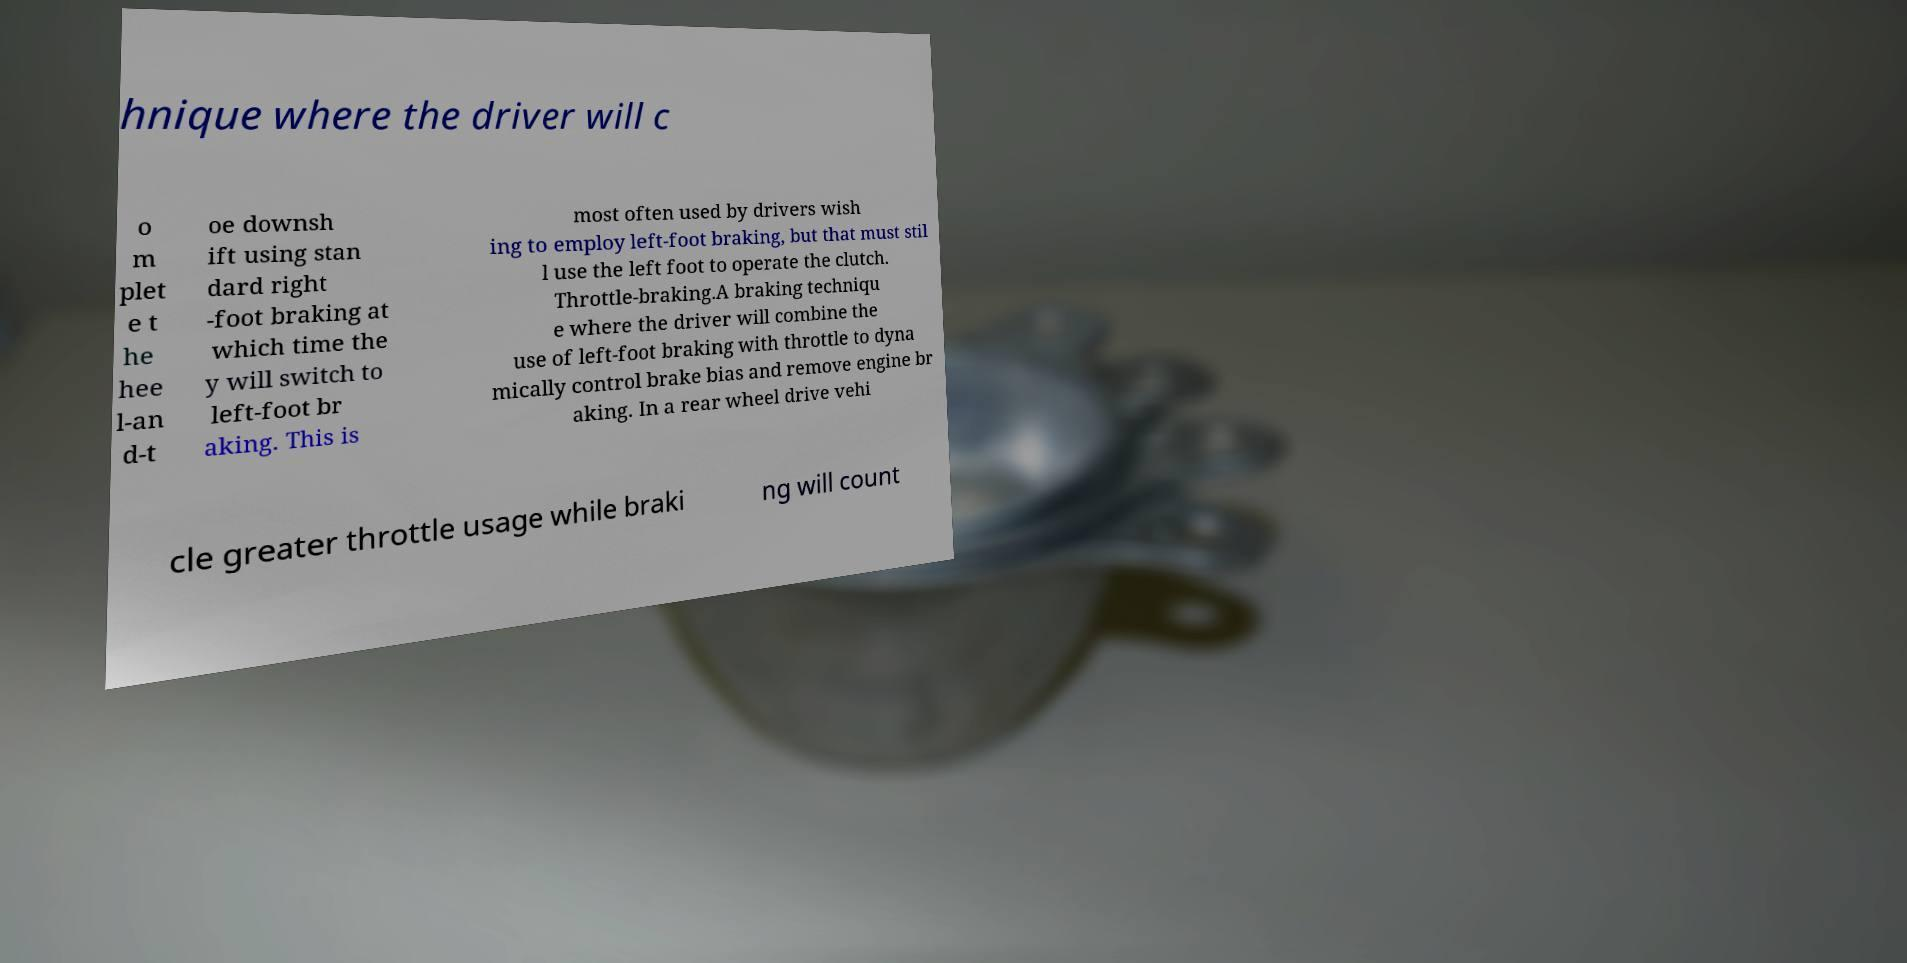Can you read and provide the text displayed in the image?This photo seems to have some interesting text. Can you extract and type it out for me? hnique where the driver will c o m plet e t he hee l-an d-t oe downsh ift using stan dard right -foot braking at which time the y will switch to left-foot br aking. This is most often used by drivers wish ing to employ left-foot braking, but that must stil l use the left foot to operate the clutch. Throttle-braking.A braking techniqu e where the driver will combine the use of left-foot braking with throttle to dyna mically control brake bias and remove engine br aking. In a rear wheel drive vehi cle greater throttle usage while braki ng will count 